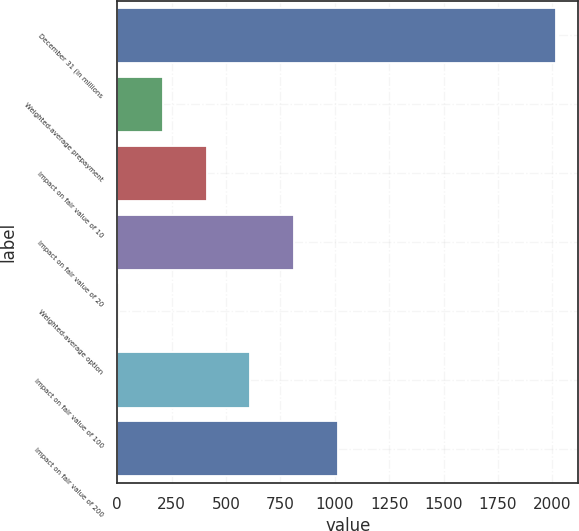Convert chart. <chart><loc_0><loc_0><loc_500><loc_500><bar_chart><fcel>December 31 (in millions<fcel>Weighted-average prepayment<fcel>Impact on fair value of 10<fcel>Impact on fair value of 20<fcel>Weighted-average option<fcel>Impact on fair value of 100<fcel>Impact on fair value of 200<nl><fcel>2018<fcel>209.63<fcel>410.56<fcel>812.42<fcel>8.7<fcel>611.49<fcel>1013.35<nl></chart> 